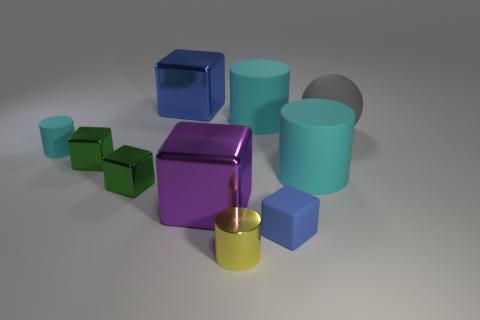Which object stands out the most and why? The purple cube stands out prominently due to its vibrant color which contrasts with the more muted tones of the other objects. Its reflective surface also catches the light more than the matte surfaces around it, making it a focal point. 